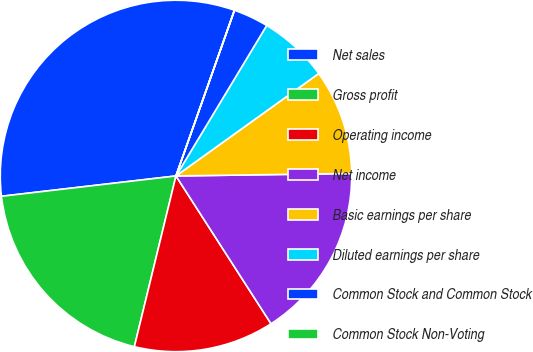<chart> <loc_0><loc_0><loc_500><loc_500><pie_chart><fcel>Net sales<fcel>Gross profit<fcel>Operating income<fcel>Net income<fcel>Basic earnings per share<fcel>Diluted earnings per share<fcel>Common Stock and Common Stock<fcel>Common Stock Non-Voting<nl><fcel>32.24%<fcel>19.35%<fcel>12.9%<fcel>16.13%<fcel>9.68%<fcel>6.46%<fcel>3.23%<fcel>0.01%<nl></chart> 